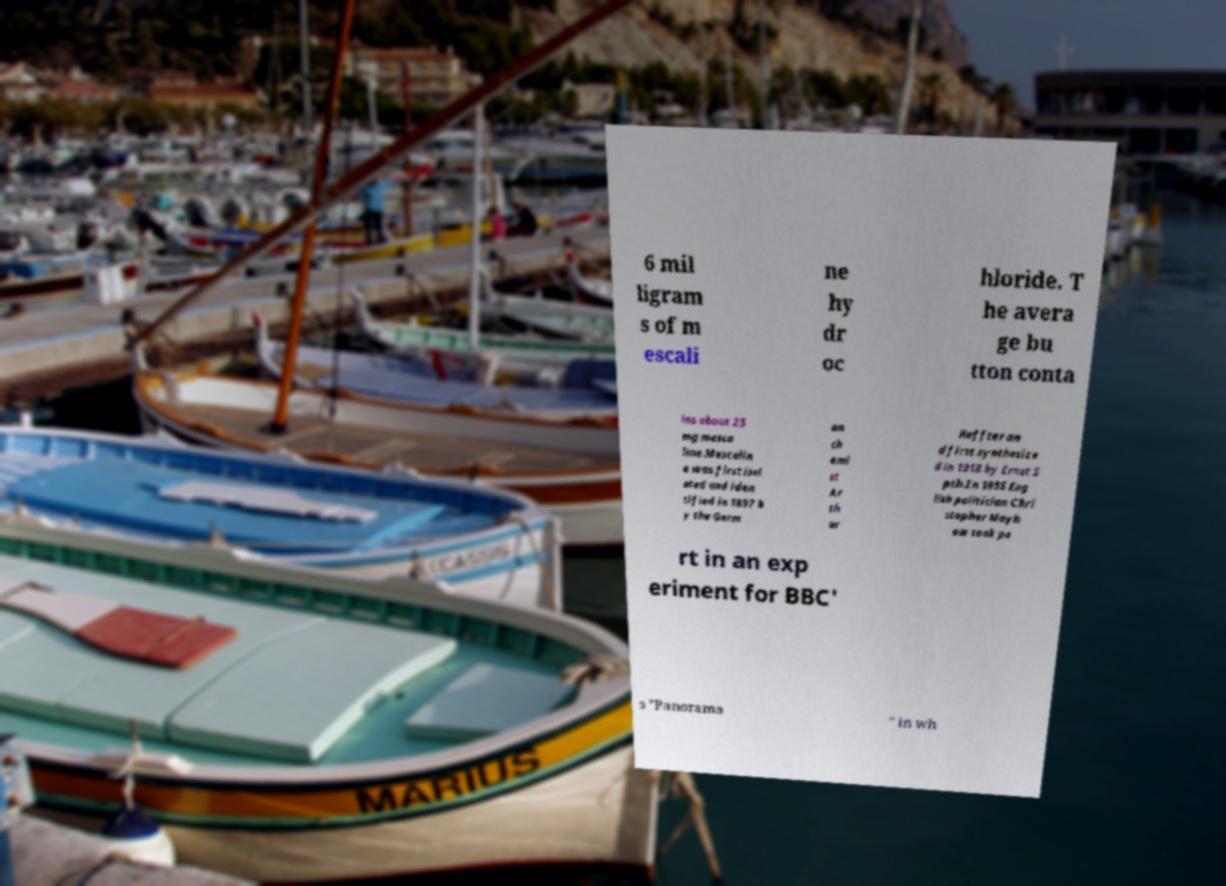What messages or text are displayed in this image? I need them in a readable, typed format. 6 mil ligram s of m escali ne hy dr oc hloride. T he avera ge bu tton conta ins about 25 mg mesca line.Mescalin e was first isol ated and iden tified in 1897 b y the Germ an ch emi st Ar th ur Heffter an d first synthesize d in 1918 by Ernst S pth.In 1955 Eng lish politician Chri stopher Mayh ew took pa rt in an exp eriment for BBC' s "Panorama " in wh 